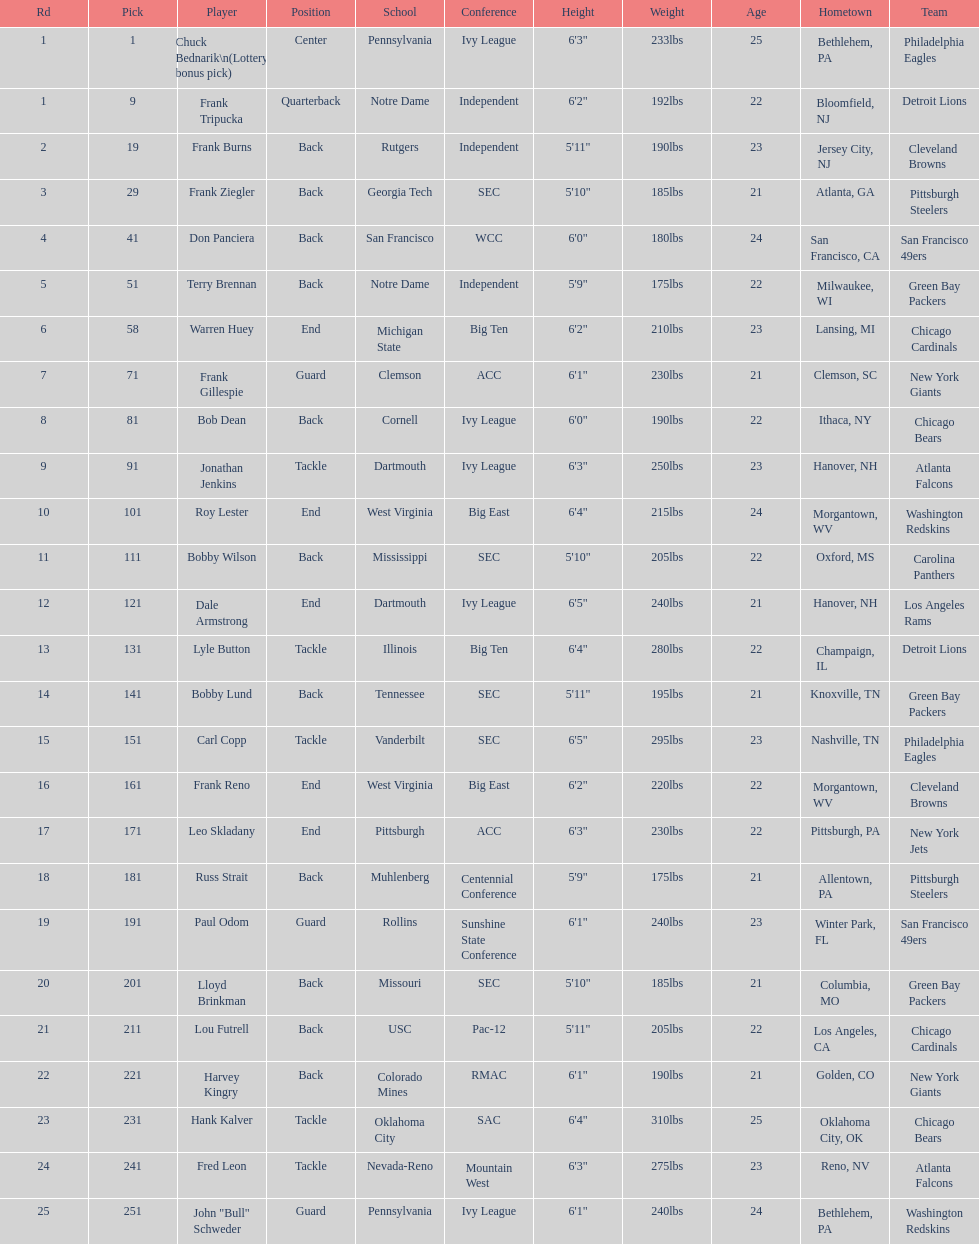Who was picked after frank burns? Frank Ziegler. 